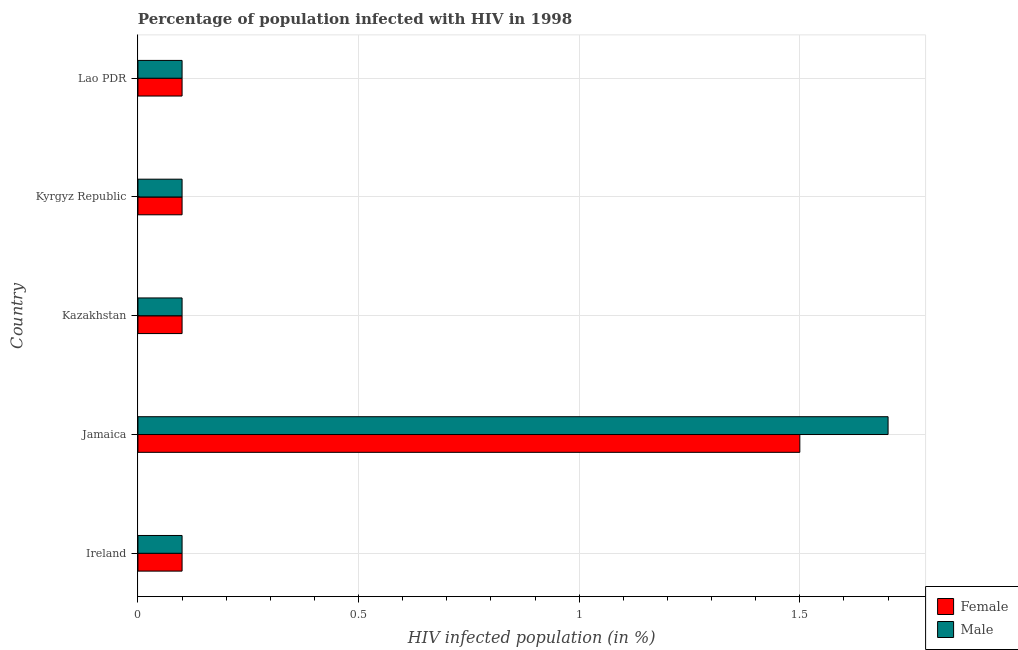How many different coloured bars are there?
Give a very brief answer. 2. How many groups of bars are there?
Offer a very short reply. 5. Are the number of bars on each tick of the Y-axis equal?
Give a very brief answer. Yes. How many bars are there on the 1st tick from the top?
Offer a very short reply. 2. How many bars are there on the 3rd tick from the bottom?
Provide a succinct answer. 2. What is the label of the 4th group of bars from the top?
Give a very brief answer. Jamaica. Across all countries, what is the maximum percentage of females who are infected with hiv?
Give a very brief answer. 1.5. Across all countries, what is the minimum percentage of females who are infected with hiv?
Give a very brief answer. 0.1. In which country was the percentage of males who are infected with hiv maximum?
Provide a short and direct response. Jamaica. In which country was the percentage of males who are infected with hiv minimum?
Ensure brevity in your answer.  Ireland. What is the total percentage of females who are infected with hiv in the graph?
Provide a short and direct response. 1.9. What is the difference between the percentage of males who are infected with hiv in Kyrgyz Republic and that in Lao PDR?
Give a very brief answer. 0. What is the difference between the percentage of males who are infected with hiv in Kazakhstan and the percentage of females who are infected with hiv in Jamaica?
Keep it short and to the point. -1.4. What is the average percentage of females who are infected with hiv per country?
Give a very brief answer. 0.38. What is the ratio of the percentage of males who are infected with hiv in Kazakhstan to that in Lao PDR?
Ensure brevity in your answer.  1. Is the difference between the percentage of males who are infected with hiv in Ireland and Lao PDR greater than the difference between the percentage of females who are infected with hiv in Ireland and Lao PDR?
Your answer should be compact. No. What is the difference between the highest and the second highest percentage of males who are infected with hiv?
Give a very brief answer. 1.6. What is the difference between the highest and the lowest percentage of females who are infected with hiv?
Ensure brevity in your answer.  1.4. Is the sum of the percentage of males who are infected with hiv in Kyrgyz Republic and Lao PDR greater than the maximum percentage of females who are infected with hiv across all countries?
Offer a very short reply. No. What does the 1st bar from the top in Jamaica represents?
Offer a very short reply. Male. What does the 2nd bar from the bottom in Jamaica represents?
Provide a succinct answer. Male. How many bars are there?
Ensure brevity in your answer.  10. Are all the bars in the graph horizontal?
Offer a very short reply. Yes. Does the graph contain any zero values?
Offer a very short reply. No. How many legend labels are there?
Offer a terse response. 2. What is the title of the graph?
Your answer should be very brief. Percentage of population infected with HIV in 1998. Does "Methane" appear as one of the legend labels in the graph?
Your response must be concise. No. What is the label or title of the X-axis?
Your answer should be compact. HIV infected population (in %). What is the label or title of the Y-axis?
Make the answer very short. Country. What is the HIV infected population (in %) in Female in Kazakhstan?
Offer a terse response. 0.1. What is the HIV infected population (in %) of Male in Kazakhstan?
Make the answer very short. 0.1. What is the HIV infected population (in %) in Female in Kyrgyz Republic?
Provide a succinct answer. 0.1. What is the HIV infected population (in %) in Male in Lao PDR?
Offer a terse response. 0.1. Across all countries, what is the maximum HIV infected population (in %) in Female?
Give a very brief answer. 1.5. Across all countries, what is the minimum HIV infected population (in %) in Female?
Ensure brevity in your answer.  0.1. What is the difference between the HIV infected population (in %) of Female in Ireland and that in Jamaica?
Give a very brief answer. -1.4. What is the difference between the HIV infected population (in %) in Male in Ireland and that in Jamaica?
Your answer should be compact. -1.6. What is the difference between the HIV infected population (in %) in Female in Ireland and that in Kazakhstan?
Offer a terse response. 0. What is the difference between the HIV infected population (in %) of Male in Ireland and that in Kazakhstan?
Provide a succinct answer. 0. What is the difference between the HIV infected population (in %) in Male in Ireland and that in Lao PDR?
Your answer should be compact. 0. What is the difference between the HIV infected population (in %) of Female in Jamaica and that in Kazakhstan?
Make the answer very short. 1.4. What is the difference between the HIV infected population (in %) of Male in Jamaica and that in Kazakhstan?
Ensure brevity in your answer.  1.6. What is the difference between the HIV infected population (in %) of Male in Jamaica and that in Lao PDR?
Provide a short and direct response. 1.6. What is the difference between the HIV infected population (in %) of Female in Kazakhstan and that in Kyrgyz Republic?
Provide a succinct answer. 0. What is the difference between the HIV infected population (in %) in Female in Kazakhstan and that in Lao PDR?
Give a very brief answer. 0. What is the difference between the HIV infected population (in %) in Male in Kyrgyz Republic and that in Lao PDR?
Make the answer very short. 0. What is the difference between the HIV infected population (in %) of Female in Ireland and the HIV infected population (in %) of Male in Jamaica?
Make the answer very short. -1.6. What is the difference between the HIV infected population (in %) of Female in Jamaica and the HIV infected population (in %) of Male in Kazakhstan?
Offer a terse response. 1.4. What is the difference between the HIV infected population (in %) in Female in Jamaica and the HIV infected population (in %) in Male in Kyrgyz Republic?
Offer a very short reply. 1.4. What is the difference between the HIV infected population (in %) in Female in Kazakhstan and the HIV infected population (in %) in Male in Kyrgyz Republic?
Your answer should be compact. 0. What is the average HIV infected population (in %) in Female per country?
Provide a succinct answer. 0.38. What is the average HIV infected population (in %) in Male per country?
Your answer should be very brief. 0.42. What is the difference between the HIV infected population (in %) of Female and HIV infected population (in %) of Male in Jamaica?
Make the answer very short. -0.2. What is the difference between the HIV infected population (in %) of Female and HIV infected population (in %) of Male in Kazakhstan?
Keep it short and to the point. 0. What is the difference between the HIV infected population (in %) in Female and HIV infected population (in %) in Male in Kyrgyz Republic?
Keep it short and to the point. 0. What is the difference between the HIV infected population (in %) of Female and HIV infected population (in %) of Male in Lao PDR?
Make the answer very short. 0. What is the ratio of the HIV infected population (in %) of Female in Ireland to that in Jamaica?
Your response must be concise. 0.07. What is the ratio of the HIV infected population (in %) of Male in Ireland to that in Jamaica?
Your answer should be compact. 0.06. What is the ratio of the HIV infected population (in %) of Male in Ireland to that in Kazakhstan?
Provide a succinct answer. 1. What is the ratio of the HIV infected population (in %) in Male in Ireland to that in Kyrgyz Republic?
Your answer should be compact. 1. What is the ratio of the HIV infected population (in %) of Female in Ireland to that in Lao PDR?
Provide a succinct answer. 1. What is the ratio of the HIV infected population (in %) in Male in Jamaica to that in Kazakhstan?
Offer a terse response. 17. What is the ratio of the HIV infected population (in %) in Female in Jamaica to that in Kyrgyz Republic?
Your answer should be very brief. 15. What is the ratio of the HIV infected population (in %) in Male in Jamaica to that in Lao PDR?
Your answer should be compact. 17. What is the ratio of the HIV infected population (in %) of Female in Kazakhstan to that in Kyrgyz Republic?
Offer a terse response. 1. What is the ratio of the HIV infected population (in %) of Male in Kazakhstan to that in Kyrgyz Republic?
Give a very brief answer. 1. What is the ratio of the HIV infected population (in %) in Female in Kazakhstan to that in Lao PDR?
Your answer should be compact. 1. What is the ratio of the HIV infected population (in %) in Female in Kyrgyz Republic to that in Lao PDR?
Your answer should be very brief. 1. What is the ratio of the HIV infected population (in %) in Male in Kyrgyz Republic to that in Lao PDR?
Your answer should be compact. 1. What is the difference between the highest and the second highest HIV infected population (in %) of Female?
Your answer should be very brief. 1.4. 